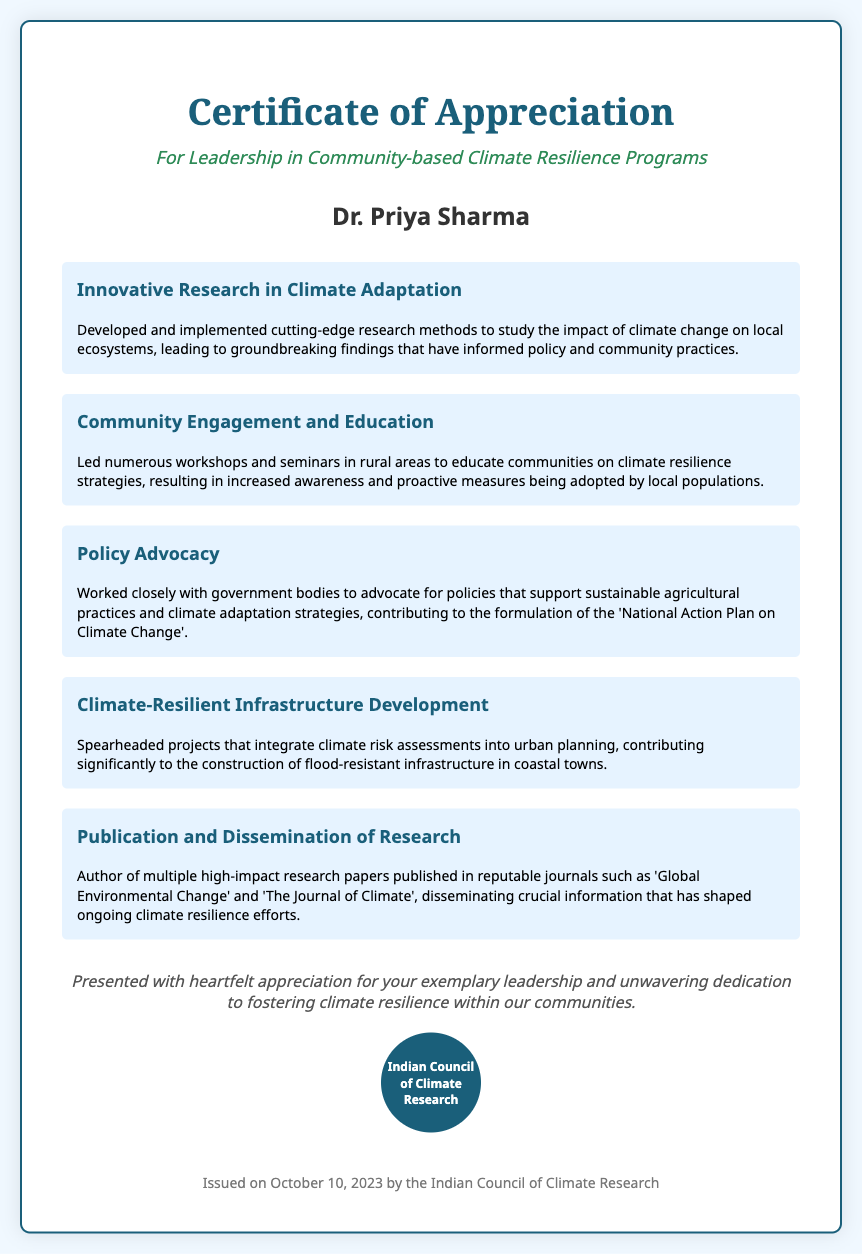What is the title of the certificate? The title is prominently displayed at the top of the document, recognizing the recipient's achievements.
Answer: Certificate of Appreciation Who is the recipient of the certificate? The recipient's name is mentioned clearly, indicating who is being recognized for their contributions.
Answer: Dr. Priya Sharma What date was the certificate issued? The document states the date of issue in the footer section, providing context for when the recognition took place.
Answer: October 10, 2023 What organization issued the certificate? The footer notes the issuing body, which contributes to the authority of the recognition provided in the certificate.
Answer: Indian Council of Climate Research How many achievements are highlighted in the certificate? The number of achievements listed reflects the recipient's significant contributions and efforts in the field of climate resilience.
Answer: Five Which achievement focuses on community workshops? The specific entry showcases the recipient's proactive engagement with communities to enhance understanding of climate issues.
Answer: Community Engagement and Education What is one area of research mentioned in the achievements? This highlights the significant contributions made by the recipient in understanding the complexities of climate change.
Answer: Innovative Research in Climate Adaptation What is the significance of the seal on the certificate? The seal reinforces the authenticity and prestige of the certificate, denoting it as an official recognition from a reputable body.
Answer: Indian Council of Climate Research 